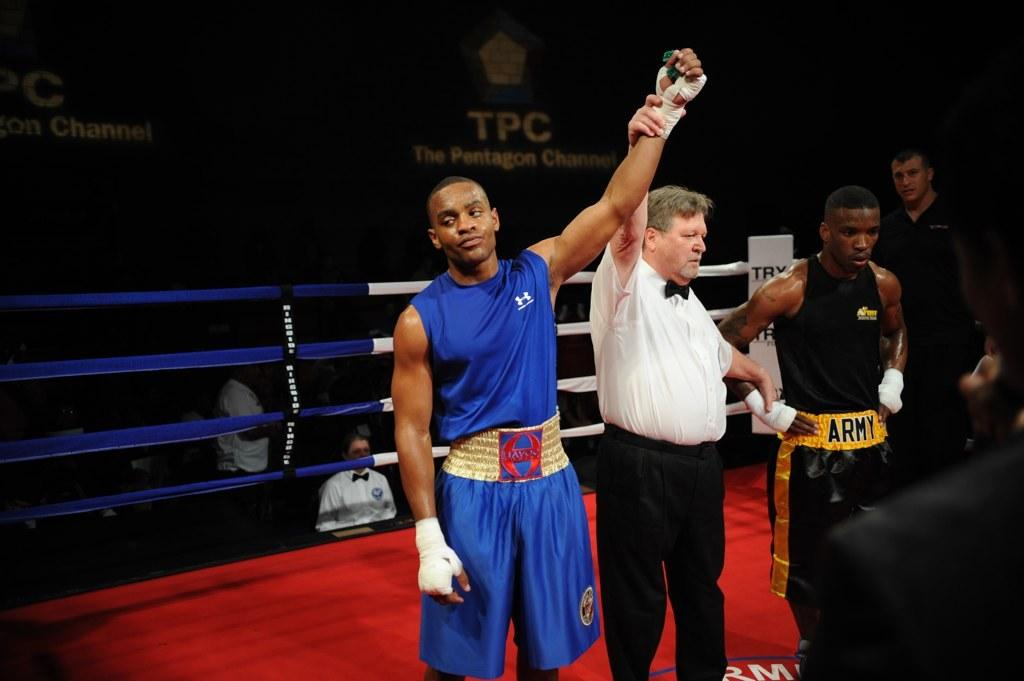<image>
Provide a brief description of the given image. A man in a boxing ring with shorts that say army on them 